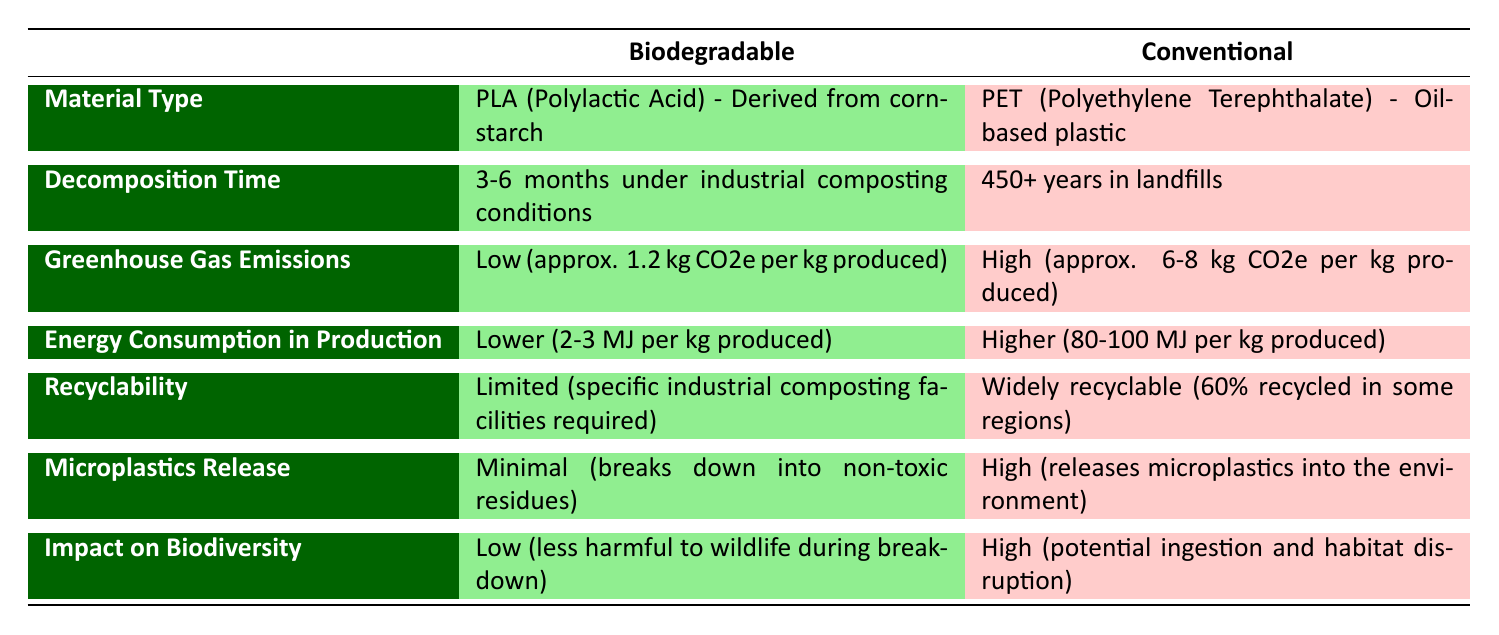What is the material type for biodegradable packaging? The table shows that the material type for biodegradable packaging is "PLA (Polylactic Acid) - Derived from cornstarch."
Answer: PLA (Polylactic Acid) - Derived from cornstarch How long does it take for conventional packaging to decompose? From the table, the decomposition time for conventional packaging is "450+ years in landfills."
Answer: 450+ years in landfills What is the difference in greenhouse gas emissions per kg produced between biodegradable and conventional packaging? The table states that biodegradable emissions are approximately 1.2 kg CO2e, while conventional emissions range from 6 to 8 kg CO2e. To find the difference, we can take the average of conventional emissions: (6 + 8) / 2 = 7 kg CO2e, making the difference approximately 7 - 1.2 = 5.8 kg CO2e.
Answer: 5.8 kg CO2e Is the energy consumption in production of biodegradable packaging lower than that of conventional packaging? According to the table, biodegradable packaging has an energy consumption of "2-3 MJ per kg produced," while conventional packaging has "80-100 MJ per kg produced." Since 2-3 MJ is less than 80-100 MJ, the answer is yes.
Answer: Yes What are the implications of microplastics release from conventional packaging? The table indicates that conventional packaging releases high amounts of microplastics into the environment, which poses risks to ecosystems and wildlife. This can lead to ingestion by animals and habitat disruption.
Answer: High risk to ecosystems and wildlife What is the total energy consumption range for producing both biodegradable and conventional packaging? The table shows that biodegradable packaging uses "2-3 MJ per kg," and conventional packaging uses "80-100 MJ per kg." To get the total range, we sum the lower bounds (2 + 80 = 82 MJ) and the upper bounds (3 + 100 = 103 MJ). Thus, the total energy consumption range is from 82 to 103 MJ per kg produced.
Answer: 82 to 103 MJ per kg Does biodegradable packaging release microplastics? It is stated in the table that biodegradable packaging has "minimal" microplastics release. This means that it does not significantly contribute to microplastics pollution. Therefore, the answer is no.
Answer: No How does the impact on biodiversity compare between biodegradable and conventional packaging? The table clearly states that biodegradable packaging has a "Low" impact on biodiversity, while conventional packaging has a "High" impact, indicating that conventional packaging poses greater risks to wildlife and habitats.
Answer: Conventional packaging has a high impact on biodiversity What is the average decomposition time for biodegradable packaging? The table provides a range of 3-6 months for the decomposition of biodegradable packaging. To find the average, we add the two values and divide by 2: (3 + 6) / 2 = 4.5 months.
Answer: 4.5 months 